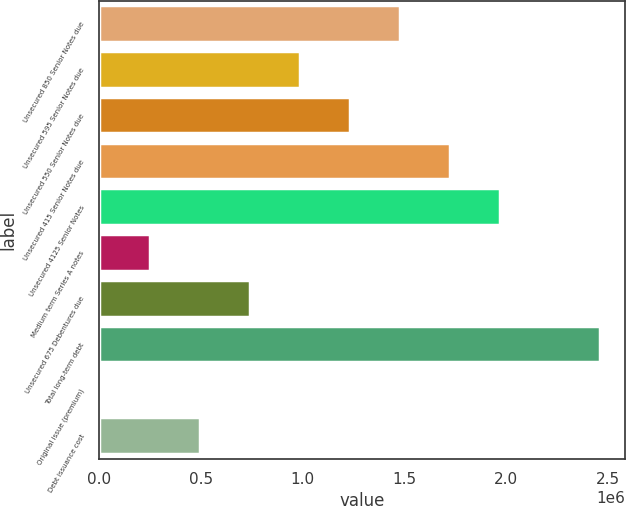<chart> <loc_0><loc_0><loc_500><loc_500><bar_chart><fcel>Unsecured 850 Senior Notes due<fcel>Unsecured 595 Senior Notes due<fcel>Unsecured 550 Senior Notes due<fcel>Unsecured 415 Senior Notes due<fcel>Unsecured 4125 Senior Notes<fcel>Medium term Series A notes<fcel>Unsecured 675 Debentures due<fcel>Total long-term debt<fcel>Original issue (premium)<fcel>Debt issuance cost<nl><fcel>1.47771e+06<fcel>986562<fcel>1.23214e+06<fcel>1.72328e+06<fcel>1.96885e+06<fcel>249843<fcel>740989<fcel>2.46e+06<fcel>4270<fcel>495416<nl></chart> 